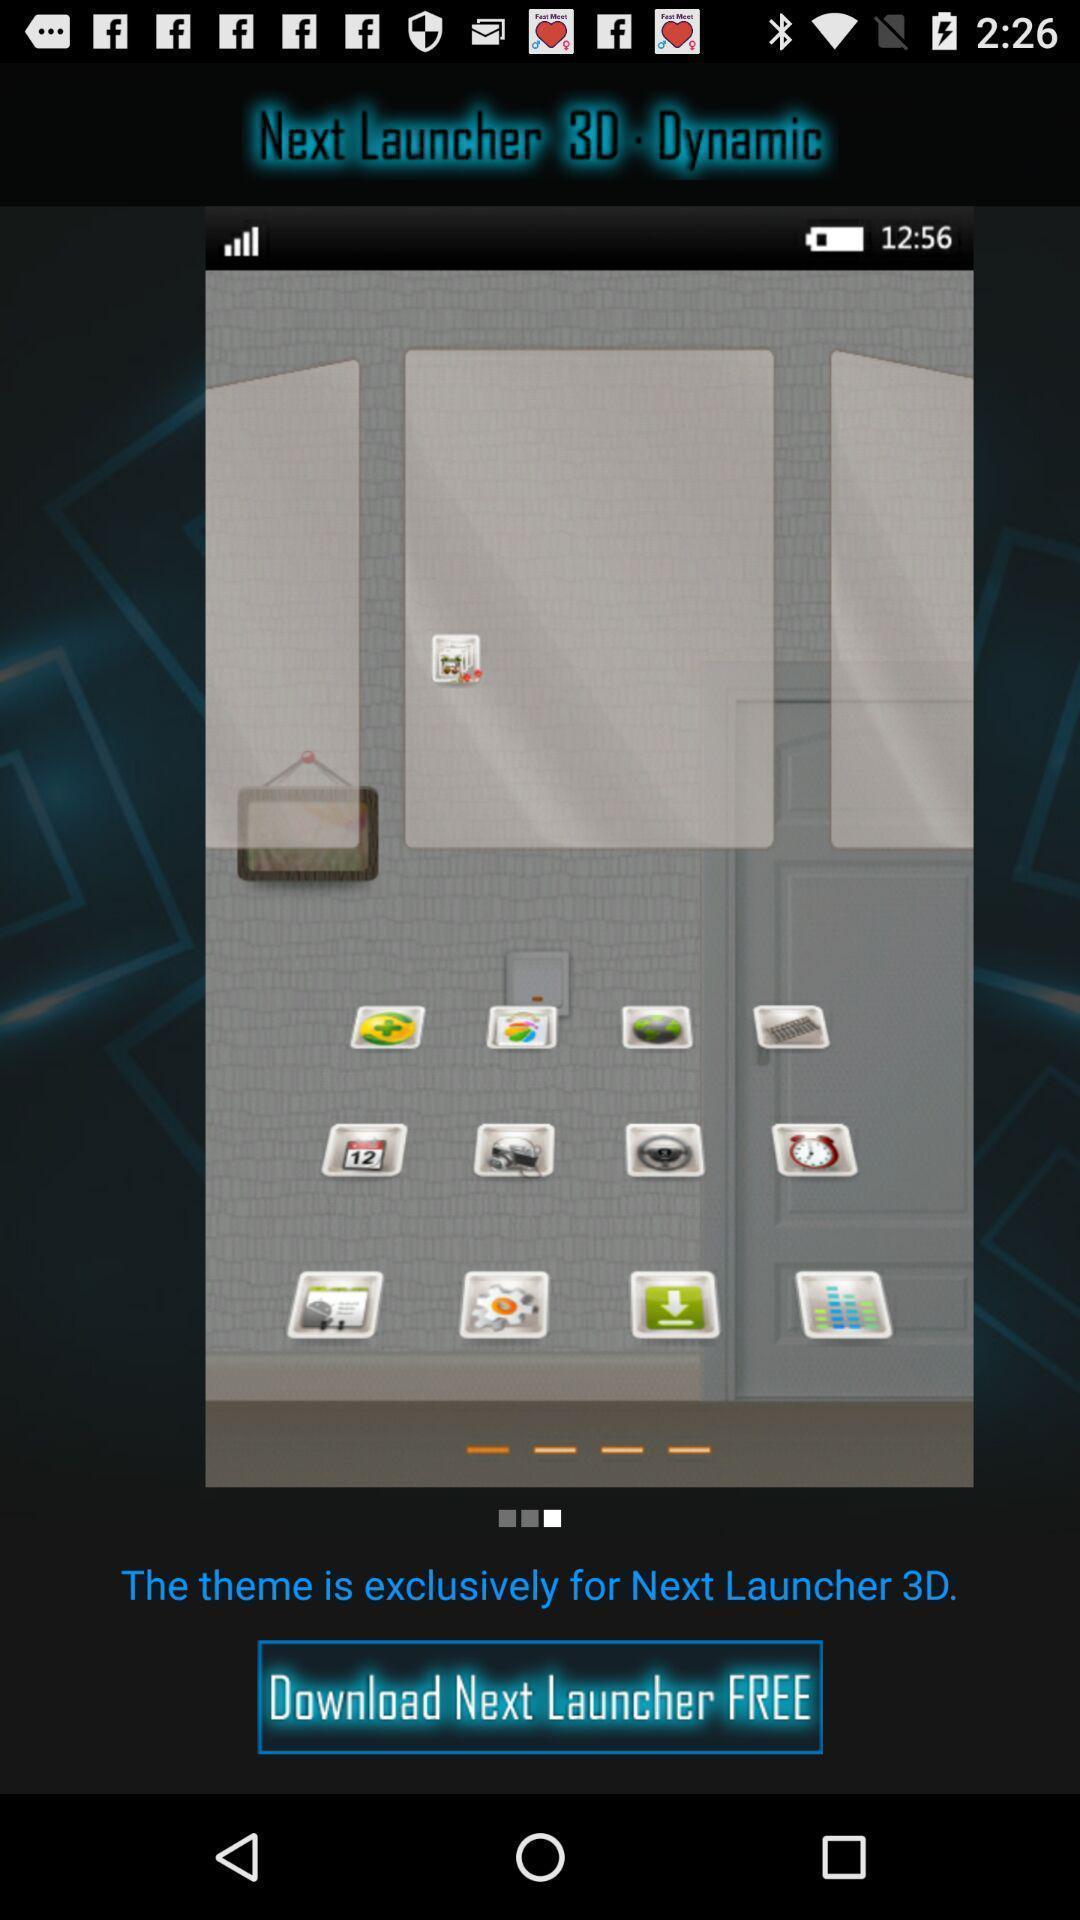Give me a narrative description of this picture. Page showing the new launch theme. 